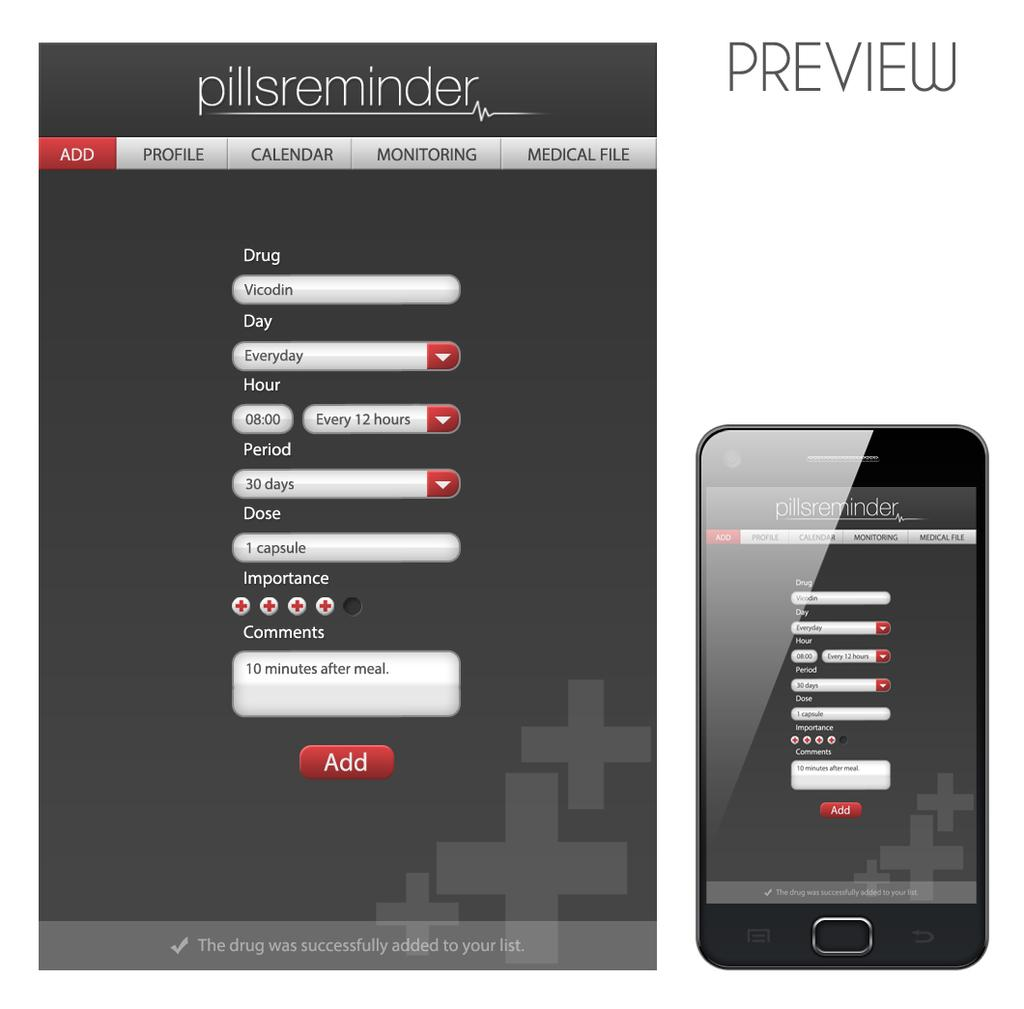What object is located on the right side of the image? There is a phone on the right side of the image. What is displayed on the phone's screen? There is a mobile screenshot visible in the image. Can you describe the content of the screenshot? There is text on top of the screenshot. What shape is the wool taking in the image? There is no wool present in the image. How many family members are visible in the image? There are no family members visible in the image; it only features a phone with a screenshot. 